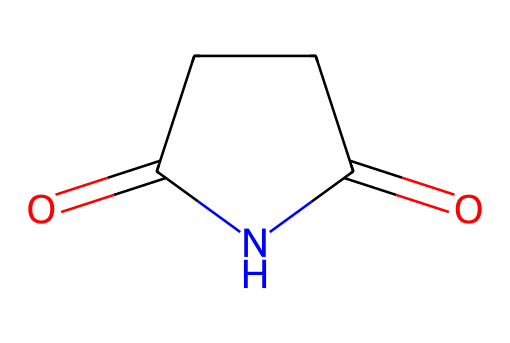How many carbon atoms are in this molecule? By examining the SMILES notation, O=C1CCC(=O)N1, we can identify that there are four carbon atoms represented in the structure (C1 and the three C's next to it).
Answer: four What functional groups are present in this molecule? Looking at the structure, we see a carbonyl group (C=O) and an imide group (N-C=O). Therefore, the functional groups present are both a carbonyl and an imide.
Answer: carbonyl and imide What is the total number of nitrogen atoms in this structure? The SMILES representation contains one nitrogen atom (indicated by the letter N), which is part of the imide group.
Answer: one What type of compound is this molecule classified as? The presence of the imide functional group indicates that this compound belongs to the category of imides, which are characterized by a nitrogen atom bonded to two acyl groups.
Answer: imide What kind of reaction would likely form this type of compound? Imides can typically be formed from the reaction of an acid anhydride with an amine, in which a dehydration occurs that eliminates water as a byproduct.
Answer: dehydration synthesis What is the significance of imide-containing organic molecules in astrobiology? Imide-containing organic molecules are considered significant in astrobiology as they may act as potential precursors to the molecules of life, contributing to the understanding of organic chemistry in space environments.
Answer: potential precursors to life 